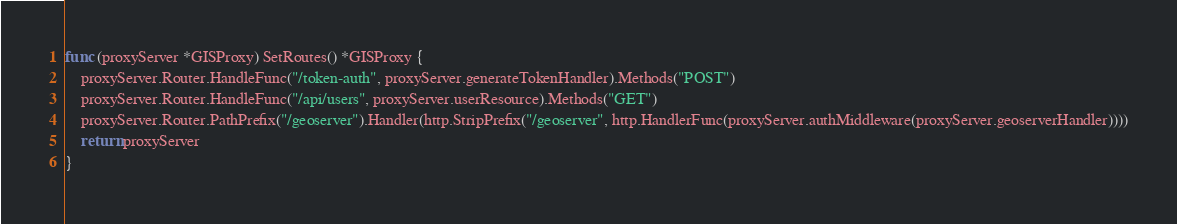<code> <loc_0><loc_0><loc_500><loc_500><_Go_>func (proxyServer *GISProxy) SetRoutes() *GISProxy {
	proxyServer.Router.HandleFunc("/token-auth", proxyServer.generateTokenHandler).Methods("POST")
	proxyServer.Router.HandleFunc("/api/users", proxyServer.userResource).Methods("GET")
	proxyServer.Router.PathPrefix("/geoserver").Handler(http.StripPrefix("/geoserver", http.HandlerFunc(proxyServer.authMiddleware(proxyServer.geoserverHandler))))
	return proxyServer
}
</code> 